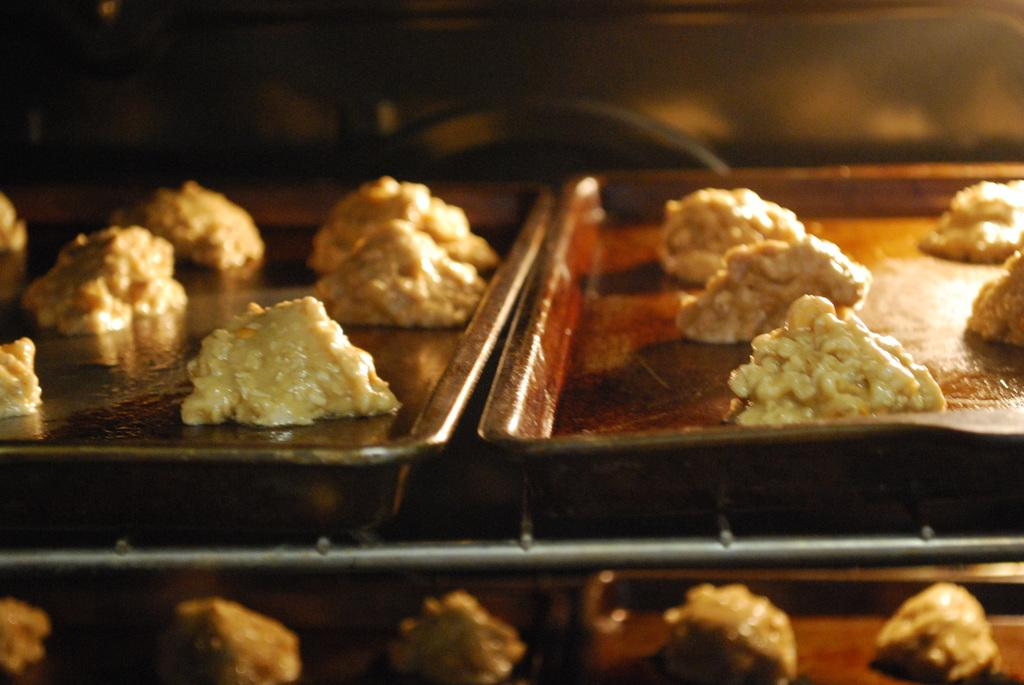What type of food can be seen in the image? There are cookies in the image. How are the cookies arranged or organized in the image? The cookies are in bakery trays. What is the reaction of the cookies when they are placed in the oven? The image does not show the cookies being placed in the oven or their reaction, as it only depicts the cookies in bakery trays. 